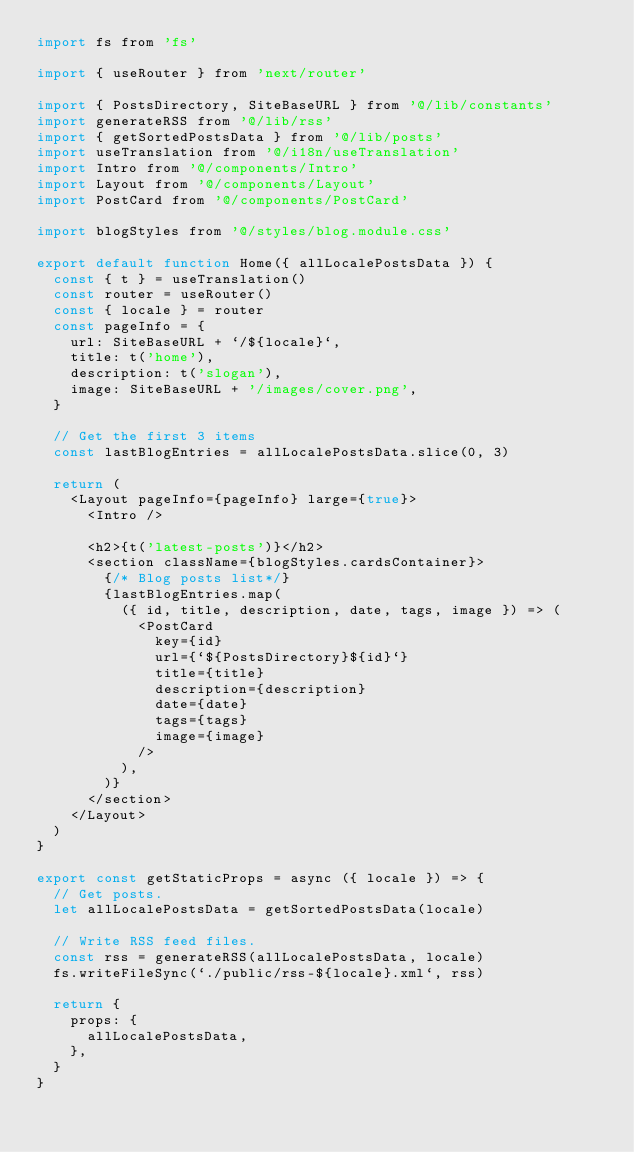Convert code to text. <code><loc_0><loc_0><loc_500><loc_500><_JavaScript_>import fs from 'fs'

import { useRouter } from 'next/router'

import { PostsDirectory, SiteBaseURL } from '@/lib/constants'
import generateRSS from '@/lib/rss'
import { getSortedPostsData } from '@/lib/posts'
import useTranslation from '@/i18n/useTranslation'
import Intro from '@/components/Intro'
import Layout from '@/components/Layout'
import PostCard from '@/components/PostCard'

import blogStyles from '@/styles/blog.module.css'

export default function Home({ allLocalePostsData }) {
  const { t } = useTranslation()
  const router = useRouter()
  const { locale } = router
  const pageInfo = {
    url: SiteBaseURL + `/${locale}`,
    title: t('home'),
    description: t('slogan'),
    image: SiteBaseURL + '/images/cover.png',
  }

  // Get the first 3 items
  const lastBlogEntries = allLocalePostsData.slice(0, 3)

  return (
    <Layout pageInfo={pageInfo} large={true}>
      <Intro />

      <h2>{t('latest-posts')}</h2>
      <section className={blogStyles.cardsContainer}>
        {/* Blog posts list*/}
        {lastBlogEntries.map(
          ({ id, title, description, date, tags, image }) => (
            <PostCard
              key={id}
              url={`${PostsDirectory}${id}`}
              title={title}
              description={description}
              date={date}
              tags={tags}
              image={image}
            />
          ),
        )}
      </section>
    </Layout>
  )
}

export const getStaticProps = async ({ locale }) => {
  // Get posts.
  let allLocalePostsData = getSortedPostsData(locale)

  // Write RSS feed files.
  const rss = generateRSS(allLocalePostsData, locale)
  fs.writeFileSync(`./public/rss-${locale}.xml`, rss)

  return {
    props: {
      allLocalePostsData,
    },
  }
}
</code> 